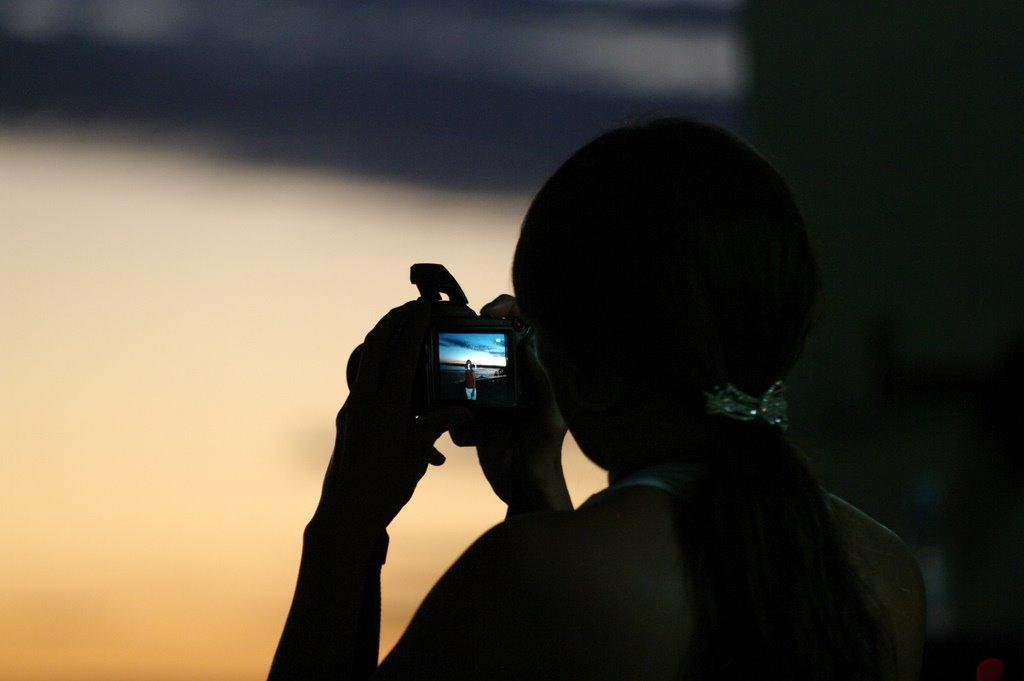Who is the main subject in the image? There is a woman in the image. What is the woman holding in the image? The woman is holding a camera. What type of iron can be seen in the woman's hand in the image? There is no iron present in the image; the woman is holding a camera. 